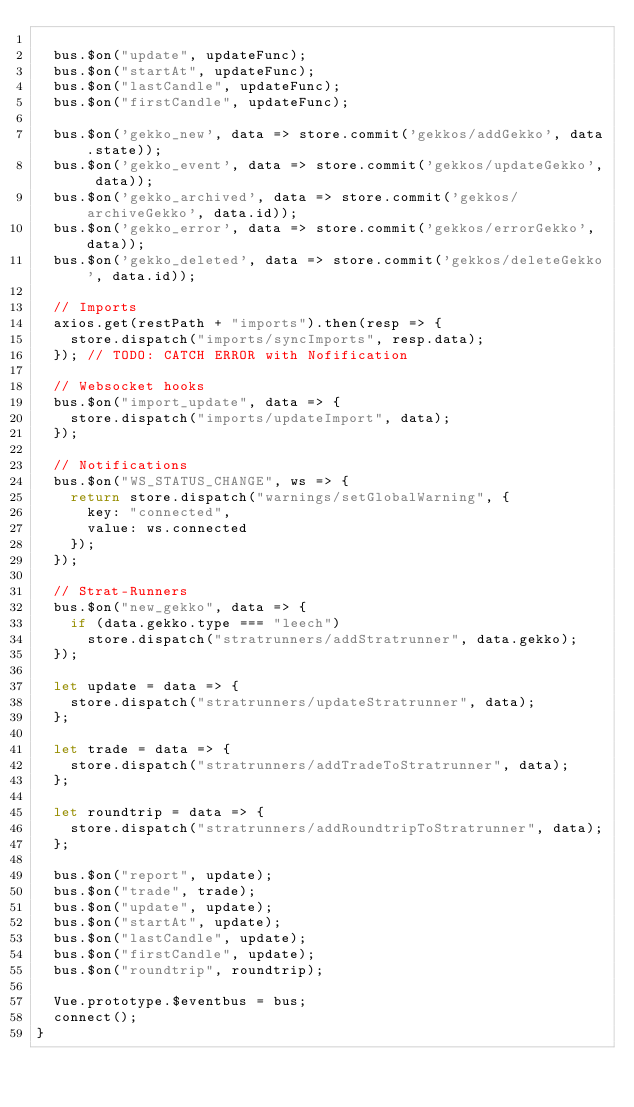Convert code to text. <code><loc_0><loc_0><loc_500><loc_500><_JavaScript_>
  bus.$on("update", updateFunc);
  bus.$on("startAt", updateFunc);
  bus.$on("lastCandle", updateFunc);
  bus.$on("firstCandle", updateFunc);

  bus.$on('gekko_new', data => store.commit('gekkos/addGekko', data.state));
  bus.$on('gekko_event', data => store.commit('gekkos/updateGekko', data));
  bus.$on('gekko_archived', data => store.commit('gekkos/archiveGekko', data.id));
  bus.$on('gekko_error', data => store.commit('gekkos/errorGekko', data));
  bus.$on('gekko_deleted', data => store.commit('gekkos/deleteGekko', data.id));

  // Imports
  axios.get(restPath + "imports").then(resp => {
    store.dispatch("imports/syncImports", resp.data);
  }); // TODO: CATCH ERROR with Nofification

  // Websocket hooks
  bus.$on("import_update", data => {
    store.dispatch("imports/updateImport", data);
  });

  // Notifications
  bus.$on("WS_STATUS_CHANGE", ws => {
    return store.dispatch("warnings/setGlobalWarning", {
      key: "connected",
      value: ws.connected
    });
  });

  // Strat-Runners
  bus.$on("new_gekko", data => {
    if (data.gekko.type === "leech")
      store.dispatch("stratrunners/addStratrunner", data.gekko);
  });

  let update = data => {
    store.dispatch("stratrunners/updateStratrunner", data);
  };

  let trade = data => {
    store.dispatch("stratrunners/addTradeToStratrunner", data);
  };

  let roundtrip = data => {
    store.dispatch("stratrunners/addRoundtripToStratrunner", data);
  };

  bus.$on("report", update);
  bus.$on("trade", trade);
  bus.$on("update", update);
  bus.$on("startAt", update);
  bus.$on("lastCandle", update);
  bus.$on("firstCandle", update);
  bus.$on("roundtrip", roundtrip);

  Vue.prototype.$eventbus = bus;
  connect();
}
</code> 